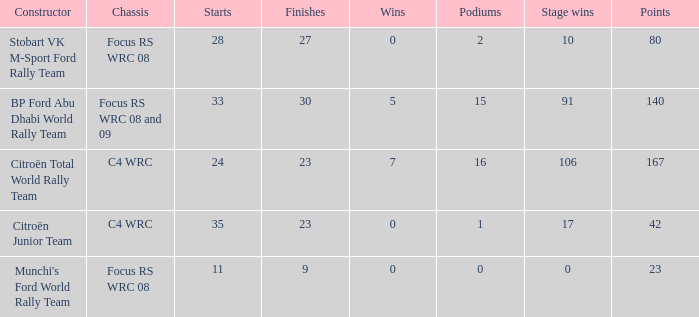What is the highest points when the chassis is focus rs wrc 08 and 09 and the stage wins is more than 91? None. 